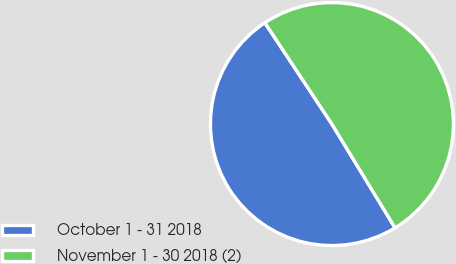<chart> <loc_0><loc_0><loc_500><loc_500><pie_chart><fcel>October 1 - 31 2018<fcel>November 1 - 30 2018 (2)<nl><fcel>49.4%<fcel>50.6%<nl></chart> 